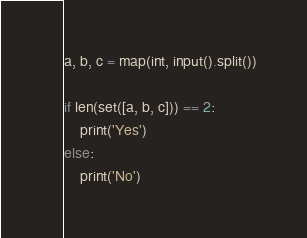<code> <loc_0><loc_0><loc_500><loc_500><_Python_>a, b, c = map(int, input().split())

if len(set([a, b, c])) == 2:
    print('Yes')
else:
    print('No')
</code> 